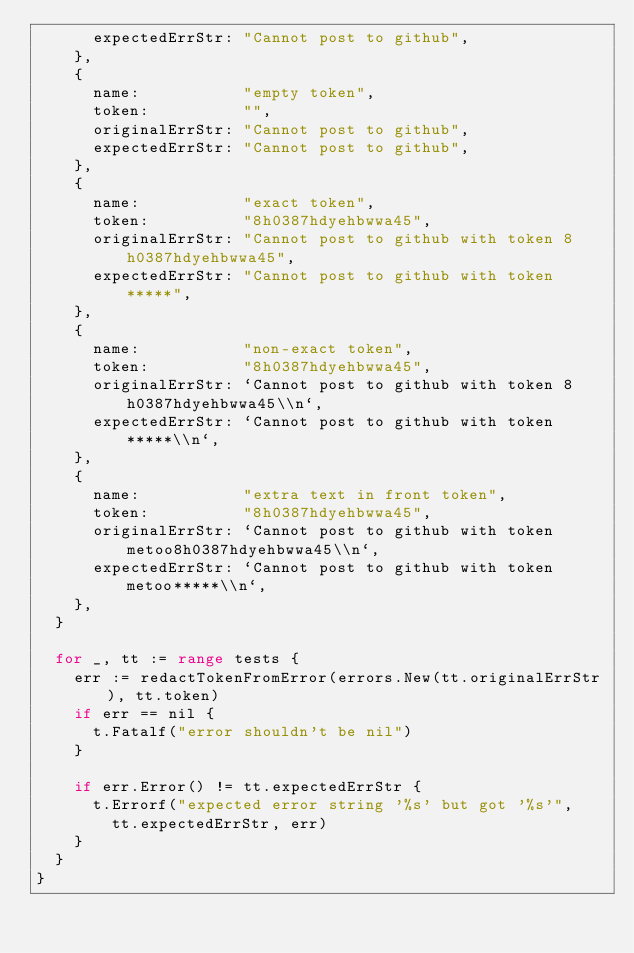<code> <loc_0><loc_0><loc_500><loc_500><_Go_>			expectedErrStr: "Cannot post to github",
		},
		{
			name:           "empty token",
			token:          "",
			originalErrStr: "Cannot post to github",
			expectedErrStr: "Cannot post to github",
		},
		{
			name:           "exact token",
			token:          "8h0387hdyehbwwa45",
			originalErrStr: "Cannot post to github with token 8h0387hdyehbwwa45",
			expectedErrStr: "Cannot post to github with token *****",
		},
		{
			name:           "non-exact token",
			token:          "8h0387hdyehbwwa45",
			originalErrStr: `Cannot post to github with token 8h0387hdyehbwwa45\\n`,
			expectedErrStr: `Cannot post to github with token *****\\n`,
		},
		{
			name:           "extra text in front token",
			token:          "8h0387hdyehbwwa45",
			originalErrStr: `Cannot post to github with token metoo8h0387hdyehbwwa45\\n`,
			expectedErrStr: `Cannot post to github with token metoo*****\\n`,
		},
	}

	for _, tt := range tests {
		err := redactTokenFromError(errors.New(tt.originalErrStr), tt.token)
		if err == nil {
			t.Fatalf("error shouldn't be nil")
		}

		if err.Error() != tt.expectedErrStr {
			t.Errorf("expected error string '%s' but got '%s'",
				tt.expectedErrStr, err)
		}
	}
}
</code> 